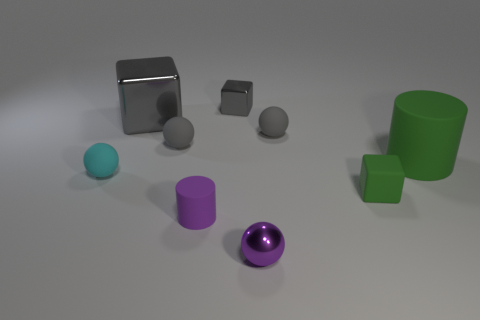How many big gray shiny blocks are there?
Give a very brief answer. 1. There is a small purple object that is the same material as the cyan sphere; what shape is it?
Your answer should be very brief. Cylinder. Does the rubber cylinder that is on the left side of the large matte thing have the same color as the big object that is to the left of the tiny rubber block?
Your response must be concise. No. Are there the same number of small cyan spheres that are on the right side of the large green cylinder and tiny purple metal balls?
Your answer should be compact. No. How many cyan things are behind the tiny shiny ball?
Ensure brevity in your answer.  1. The purple cylinder is what size?
Give a very brief answer. Small. There is a tiny cylinder that is made of the same material as the large green thing; what color is it?
Provide a succinct answer. Purple. How many cubes are the same size as the green cylinder?
Provide a succinct answer. 1. Do the large thing on the left side of the small gray metal block and the tiny purple ball have the same material?
Your response must be concise. Yes. Is the number of green cubes behind the large gray metallic cube less than the number of small gray balls?
Provide a short and direct response. Yes. 